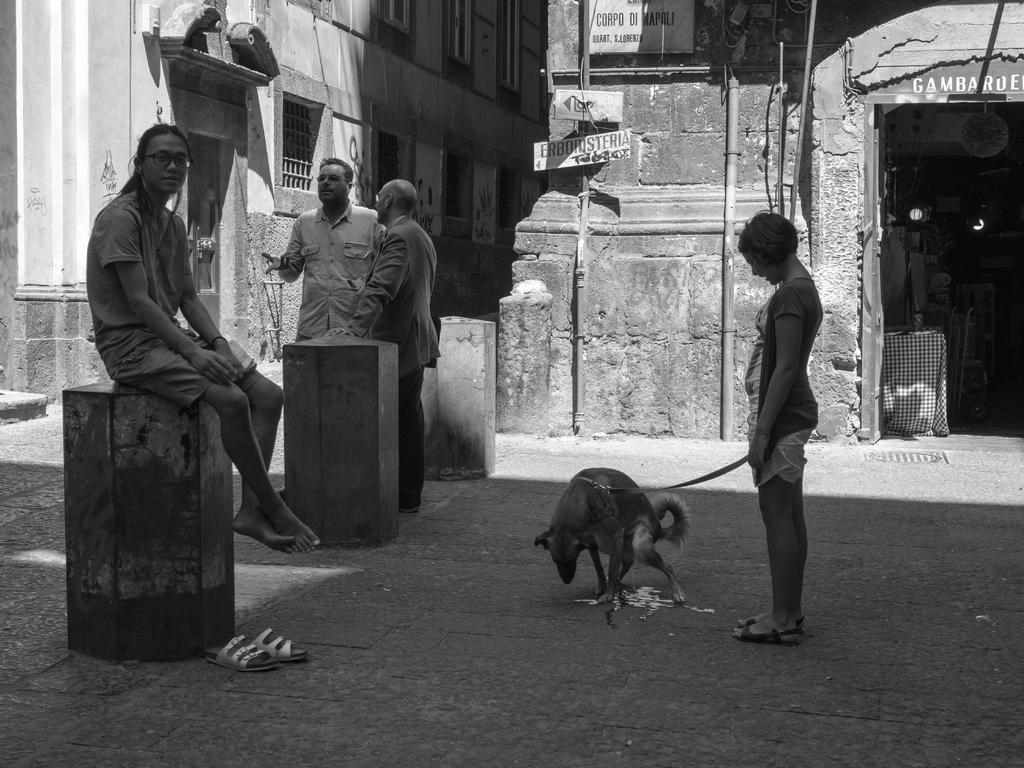What is the color scheme of the image? The image is black and white. What type of structures can be seen in the image? There are buildings in the image. What other objects are present in the image? There are boards, poles, and objects in the image. Are there any living beings in the image? Yes, there are people and a dog in the image. What else can be seen in the image? There are footwear's in the image. What type of chain can be seen connecting the buildings in the image? There is no chain connecting the buildings in the image; it is a black and white image with various structures and objects. What type of stocking is the dog wearing in the image? There is no dog wearing stockings in the image; it is a black and white image with various structures and objects. 